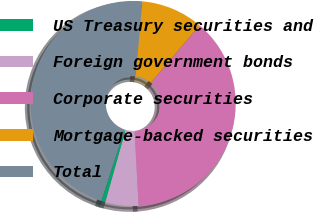<chart> <loc_0><loc_0><loc_500><loc_500><pie_chart><fcel>US Treasury securities and<fcel>Foreign government bonds<fcel>Corporate securities<fcel>Mortgage-backed securities<fcel>Total<nl><fcel>0.64%<fcel>5.22%<fcel>37.93%<fcel>9.79%<fcel>46.42%<nl></chart> 